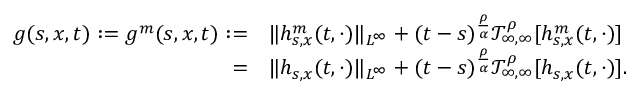Convert formula to latex. <formula><loc_0><loc_0><loc_500><loc_500>\begin{array} { r l } { g ( s , x , t ) \colon = g ^ { m } ( s , x , t ) \colon = } & { \| h _ { s , x } ^ { m } ( t , \cdot ) \| _ { L ^ { \infty } } + ( t - s ) ^ { \frac { \rho } { \alpha } } \mathcal { T } _ { \infty , \infty } ^ { \rho } [ h _ { s , x } ^ { m } ( t , \cdot ) ] } \\ { = } & { \| h _ { s , x } ( t , \cdot ) \| _ { L ^ { \infty } } + ( t - s ) ^ { \frac { \rho } { \alpha } } \mathcal { T } _ { \infty , \infty } ^ { \rho } [ h _ { s , x } ( t , \cdot ) ] . } \end{array}</formula> 